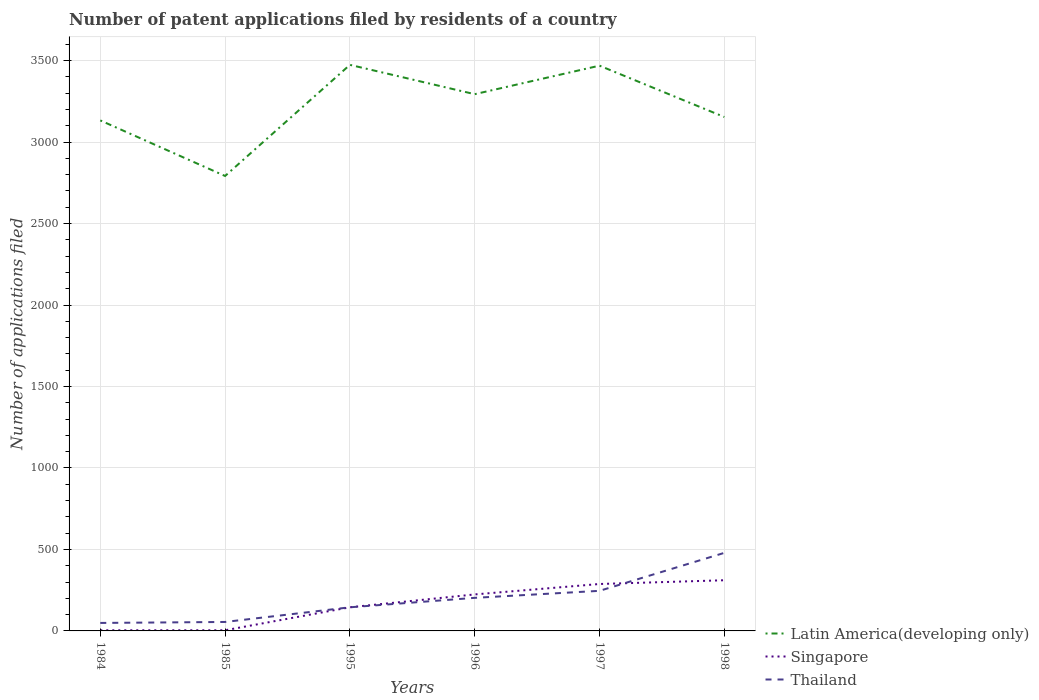Does the line corresponding to Singapore intersect with the line corresponding to Latin America(developing only)?
Keep it short and to the point. No. Is the number of lines equal to the number of legend labels?
Your answer should be very brief. Yes. What is the total number of applications filed in Thailand in the graph?
Offer a very short reply. -197. What is the difference between the highest and the second highest number of applications filed in Thailand?
Keep it short and to the point. 430. How many lines are there?
Ensure brevity in your answer.  3. How many years are there in the graph?
Ensure brevity in your answer.  6. How many legend labels are there?
Offer a very short reply. 3. What is the title of the graph?
Offer a terse response. Number of patent applications filed by residents of a country. What is the label or title of the Y-axis?
Make the answer very short. Number of applications filed. What is the Number of applications filed in Latin America(developing only) in 1984?
Provide a short and direct response. 3133. What is the Number of applications filed of Singapore in 1984?
Offer a very short reply. 4. What is the Number of applications filed in Latin America(developing only) in 1985?
Provide a succinct answer. 2792. What is the Number of applications filed in Singapore in 1985?
Give a very brief answer. 4. What is the Number of applications filed in Latin America(developing only) in 1995?
Offer a terse response. 3474. What is the Number of applications filed of Singapore in 1995?
Keep it short and to the point. 145. What is the Number of applications filed in Thailand in 1995?
Keep it short and to the point. 145. What is the Number of applications filed of Latin America(developing only) in 1996?
Provide a short and direct response. 3294. What is the Number of applications filed of Singapore in 1996?
Your answer should be compact. 224. What is the Number of applications filed in Thailand in 1996?
Provide a short and direct response. 203. What is the Number of applications filed in Latin America(developing only) in 1997?
Provide a short and direct response. 3469. What is the Number of applications filed of Singapore in 1997?
Your answer should be compact. 288. What is the Number of applications filed of Thailand in 1997?
Your response must be concise. 246. What is the Number of applications filed in Latin America(developing only) in 1998?
Your answer should be very brief. 3154. What is the Number of applications filed in Singapore in 1998?
Offer a terse response. 311. What is the Number of applications filed of Thailand in 1998?
Your response must be concise. 479. Across all years, what is the maximum Number of applications filed in Latin America(developing only)?
Make the answer very short. 3474. Across all years, what is the maximum Number of applications filed of Singapore?
Provide a short and direct response. 311. Across all years, what is the maximum Number of applications filed in Thailand?
Your answer should be compact. 479. Across all years, what is the minimum Number of applications filed of Latin America(developing only)?
Give a very brief answer. 2792. Across all years, what is the minimum Number of applications filed in Thailand?
Make the answer very short. 49. What is the total Number of applications filed in Latin America(developing only) in the graph?
Offer a very short reply. 1.93e+04. What is the total Number of applications filed in Singapore in the graph?
Your answer should be very brief. 976. What is the total Number of applications filed of Thailand in the graph?
Your response must be concise. 1177. What is the difference between the Number of applications filed of Latin America(developing only) in 1984 and that in 1985?
Make the answer very short. 341. What is the difference between the Number of applications filed of Thailand in 1984 and that in 1985?
Your response must be concise. -6. What is the difference between the Number of applications filed in Latin America(developing only) in 1984 and that in 1995?
Your response must be concise. -341. What is the difference between the Number of applications filed in Singapore in 1984 and that in 1995?
Give a very brief answer. -141. What is the difference between the Number of applications filed of Thailand in 1984 and that in 1995?
Give a very brief answer. -96. What is the difference between the Number of applications filed of Latin America(developing only) in 1984 and that in 1996?
Offer a very short reply. -161. What is the difference between the Number of applications filed of Singapore in 1984 and that in 1996?
Make the answer very short. -220. What is the difference between the Number of applications filed of Thailand in 1984 and that in 1996?
Your response must be concise. -154. What is the difference between the Number of applications filed of Latin America(developing only) in 1984 and that in 1997?
Make the answer very short. -336. What is the difference between the Number of applications filed in Singapore in 1984 and that in 1997?
Your response must be concise. -284. What is the difference between the Number of applications filed in Thailand in 1984 and that in 1997?
Your answer should be compact. -197. What is the difference between the Number of applications filed of Singapore in 1984 and that in 1998?
Keep it short and to the point. -307. What is the difference between the Number of applications filed of Thailand in 1984 and that in 1998?
Your answer should be compact. -430. What is the difference between the Number of applications filed of Latin America(developing only) in 1985 and that in 1995?
Your answer should be very brief. -682. What is the difference between the Number of applications filed of Singapore in 1985 and that in 1995?
Ensure brevity in your answer.  -141. What is the difference between the Number of applications filed in Thailand in 1985 and that in 1995?
Your answer should be very brief. -90. What is the difference between the Number of applications filed in Latin America(developing only) in 1985 and that in 1996?
Ensure brevity in your answer.  -502. What is the difference between the Number of applications filed of Singapore in 1985 and that in 1996?
Your answer should be very brief. -220. What is the difference between the Number of applications filed in Thailand in 1985 and that in 1996?
Provide a short and direct response. -148. What is the difference between the Number of applications filed of Latin America(developing only) in 1985 and that in 1997?
Offer a terse response. -677. What is the difference between the Number of applications filed of Singapore in 1985 and that in 1997?
Your answer should be compact. -284. What is the difference between the Number of applications filed in Thailand in 1985 and that in 1997?
Your answer should be compact. -191. What is the difference between the Number of applications filed in Latin America(developing only) in 1985 and that in 1998?
Your answer should be very brief. -362. What is the difference between the Number of applications filed in Singapore in 1985 and that in 1998?
Make the answer very short. -307. What is the difference between the Number of applications filed of Thailand in 1985 and that in 1998?
Provide a succinct answer. -424. What is the difference between the Number of applications filed in Latin America(developing only) in 1995 and that in 1996?
Ensure brevity in your answer.  180. What is the difference between the Number of applications filed in Singapore in 1995 and that in 1996?
Ensure brevity in your answer.  -79. What is the difference between the Number of applications filed in Thailand in 1995 and that in 1996?
Provide a short and direct response. -58. What is the difference between the Number of applications filed in Latin America(developing only) in 1995 and that in 1997?
Your answer should be very brief. 5. What is the difference between the Number of applications filed of Singapore in 1995 and that in 1997?
Your answer should be compact. -143. What is the difference between the Number of applications filed in Thailand in 1995 and that in 1997?
Your answer should be very brief. -101. What is the difference between the Number of applications filed of Latin America(developing only) in 1995 and that in 1998?
Keep it short and to the point. 320. What is the difference between the Number of applications filed in Singapore in 1995 and that in 1998?
Provide a short and direct response. -166. What is the difference between the Number of applications filed in Thailand in 1995 and that in 1998?
Offer a terse response. -334. What is the difference between the Number of applications filed of Latin America(developing only) in 1996 and that in 1997?
Keep it short and to the point. -175. What is the difference between the Number of applications filed in Singapore in 1996 and that in 1997?
Offer a terse response. -64. What is the difference between the Number of applications filed of Thailand in 1996 and that in 1997?
Your answer should be very brief. -43. What is the difference between the Number of applications filed of Latin America(developing only) in 1996 and that in 1998?
Your response must be concise. 140. What is the difference between the Number of applications filed in Singapore in 1996 and that in 1998?
Make the answer very short. -87. What is the difference between the Number of applications filed of Thailand in 1996 and that in 1998?
Keep it short and to the point. -276. What is the difference between the Number of applications filed in Latin America(developing only) in 1997 and that in 1998?
Give a very brief answer. 315. What is the difference between the Number of applications filed in Singapore in 1997 and that in 1998?
Offer a very short reply. -23. What is the difference between the Number of applications filed in Thailand in 1997 and that in 1998?
Offer a very short reply. -233. What is the difference between the Number of applications filed of Latin America(developing only) in 1984 and the Number of applications filed of Singapore in 1985?
Offer a very short reply. 3129. What is the difference between the Number of applications filed in Latin America(developing only) in 1984 and the Number of applications filed in Thailand in 1985?
Your answer should be compact. 3078. What is the difference between the Number of applications filed of Singapore in 1984 and the Number of applications filed of Thailand in 1985?
Your answer should be very brief. -51. What is the difference between the Number of applications filed of Latin America(developing only) in 1984 and the Number of applications filed of Singapore in 1995?
Your answer should be compact. 2988. What is the difference between the Number of applications filed in Latin America(developing only) in 1984 and the Number of applications filed in Thailand in 1995?
Your response must be concise. 2988. What is the difference between the Number of applications filed of Singapore in 1984 and the Number of applications filed of Thailand in 1995?
Make the answer very short. -141. What is the difference between the Number of applications filed of Latin America(developing only) in 1984 and the Number of applications filed of Singapore in 1996?
Make the answer very short. 2909. What is the difference between the Number of applications filed in Latin America(developing only) in 1984 and the Number of applications filed in Thailand in 1996?
Make the answer very short. 2930. What is the difference between the Number of applications filed in Singapore in 1984 and the Number of applications filed in Thailand in 1996?
Offer a terse response. -199. What is the difference between the Number of applications filed of Latin America(developing only) in 1984 and the Number of applications filed of Singapore in 1997?
Make the answer very short. 2845. What is the difference between the Number of applications filed in Latin America(developing only) in 1984 and the Number of applications filed in Thailand in 1997?
Provide a succinct answer. 2887. What is the difference between the Number of applications filed in Singapore in 1984 and the Number of applications filed in Thailand in 1997?
Offer a very short reply. -242. What is the difference between the Number of applications filed in Latin America(developing only) in 1984 and the Number of applications filed in Singapore in 1998?
Your answer should be compact. 2822. What is the difference between the Number of applications filed of Latin America(developing only) in 1984 and the Number of applications filed of Thailand in 1998?
Provide a short and direct response. 2654. What is the difference between the Number of applications filed in Singapore in 1984 and the Number of applications filed in Thailand in 1998?
Make the answer very short. -475. What is the difference between the Number of applications filed of Latin America(developing only) in 1985 and the Number of applications filed of Singapore in 1995?
Provide a short and direct response. 2647. What is the difference between the Number of applications filed of Latin America(developing only) in 1985 and the Number of applications filed of Thailand in 1995?
Ensure brevity in your answer.  2647. What is the difference between the Number of applications filed in Singapore in 1985 and the Number of applications filed in Thailand in 1995?
Make the answer very short. -141. What is the difference between the Number of applications filed of Latin America(developing only) in 1985 and the Number of applications filed of Singapore in 1996?
Keep it short and to the point. 2568. What is the difference between the Number of applications filed in Latin America(developing only) in 1985 and the Number of applications filed in Thailand in 1996?
Ensure brevity in your answer.  2589. What is the difference between the Number of applications filed of Singapore in 1985 and the Number of applications filed of Thailand in 1996?
Ensure brevity in your answer.  -199. What is the difference between the Number of applications filed of Latin America(developing only) in 1985 and the Number of applications filed of Singapore in 1997?
Give a very brief answer. 2504. What is the difference between the Number of applications filed in Latin America(developing only) in 1985 and the Number of applications filed in Thailand in 1997?
Ensure brevity in your answer.  2546. What is the difference between the Number of applications filed of Singapore in 1985 and the Number of applications filed of Thailand in 1997?
Ensure brevity in your answer.  -242. What is the difference between the Number of applications filed of Latin America(developing only) in 1985 and the Number of applications filed of Singapore in 1998?
Keep it short and to the point. 2481. What is the difference between the Number of applications filed of Latin America(developing only) in 1985 and the Number of applications filed of Thailand in 1998?
Keep it short and to the point. 2313. What is the difference between the Number of applications filed of Singapore in 1985 and the Number of applications filed of Thailand in 1998?
Your response must be concise. -475. What is the difference between the Number of applications filed of Latin America(developing only) in 1995 and the Number of applications filed of Singapore in 1996?
Ensure brevity in your answer.  3250. What is the difference between the Number of applications filed of Latin America(developing only) in 1995 and the Number of applications filed of Thailand in 1996?
Your answer should be very brief. 3271. What is the difference between the Number of applications filed of Singapore in 1995 and the Number of applications filed of Thailand in 1996?
Provide a short and direct response. -58. What is the difference between the Number of applications filed in Latin America(developing only) in 1995 and the Number of applications filed in Singapore in 1997?
Offer a very short reply. 3186. What is the difference between the Number of applications filed in Latin America(developing only) in 1995 and the Number of applications filed in Thailand in 1997?
Keep it short and to the point. 3228. What is the difference between the Number of applications filed of Singapore in 1995 and the Number of applications filed of Thailand in 1997?
Provide a short and direct response. -101. What is the difference between the Number of applications filed of Latin America(developing only) in 1995 and the Number of applications filed of Singapore in 1998?
Your answer should be compact. 3163. What is the difference between the Number of applications filed of Latin America(developing only) in 1995 and the Number of applications filed of Thailand in 1998?
Keep it short and to the point. 2995. What is the difference between the Number of applications filed in Singapore in 1995 and the Number of applications filed in Thailand in 1998?
Ensure brevity in your answer.  -334. What is the difference between the Number of applications filed of Latin America(developing only) in 1996 and the Number of applications filed of Singapore in 1997?
Make the answer very short. 3006. What is the difference between the Number of applications filed of Latin America(developing only) in 1996 and the Number of applications filed of Thailand in 1997?
Offer a very short reply. 3048. What is the difference between the Number of applications filed of Latin America(developing only) in 1996 and the Number of applications filed of Singapore in 1998?
Offer a very short reply. 2983. What is the difference between the Number of applications filed in Latin America(developing only) in 1996 and the Number of applications filed in Thailand in 1998?
Your answer should be very brief. 2815. What is the difference between the Number of applications filed of Singapore in 1996 and the Number of applications filed of Thailand in 1998?
Your answer should be very brief. -255. What is the difference between the Number of applications filed of Latin America(developing only) in 1997 and the Number of applications filed of Singapore in 1998?
Provide a succinct answer. 3158. What is the difference between the Number of applications filed in Latin America(developing only) in 1997 and the Number of applications filed in Thailand in 1998?
Offer a terse response. 2990. What is the difference between the Number of applications filed in Singapore in 1997 and the Number of applications filed in Thailand in 1998?
Offer a terse response. -191. What is the average Number of applications filed in Latin America(developing only) per year?
Offer a very short reply. 3219.33. What is the average Number of applications filed in Singapore per year?
Your response must be concise. 162.67. What is the average Number of applications filed in Thailand per year?
Your answer should be very brief. 196.17. In the year 1984, what is the difference between the Number of applications filed of Latin America(developing only) and Number of applications filed of Singapore?
Give a very brief answer. 3129. In the year 1984, what is the difference between the Number of applications filed in Latin America(developing only) and Number of applications filed in Thailand?
Your answer should be very brief. 3084. In the year 1984, what is the difference between the Number of applications filed in Singapore and Number of applications filed in Thailand?
Provide a succinct answer. -45. In the year 1985, what is the difference between the Number of applications filed of Latin America(developing only) and Number of applications filed of Singapore?
Make the answer very short. 2788. In the year 1985, what is the difference between the Number of applications filed of Latin America(developing only) and Number of applications filed of Thailand?
Provide a short and direct response. 2737. In the year 1985, what is the difference between the Number of applications filed in Singapore and Number of applications filed in Thailand?
Your answer should be very brief. -51. In the year 1995, what is the difference between the Number of applications filed in Latin America(developing only) and Number of applications filed in Singapore?
Provide a succinct answer. 3329. In the year 1995, what is the difference between the Number of applications filed of Latin America(developing only) and Number of applications filed of Thailand?
Your response must be concise. 3329. In the year 1995, what is the difference between the Number of applications filed in Singapore and Number of applications filed in Thailand?
Make the answer very short. 0. In the year 1996, what is the difference between the Number of applications filed of Latin America(developing only) and Number of applications filed of Singapore?
Ensure brevity in your answer.  3070. In the year 1996, what is the difference between the Number of applications filed of Latin America(developing only) and Number of applications filed of Thailand?
Provide a short and direct response. 3091. In the year 1996, what is the difference between the Number of applications filed in Singapore and Number of applications filed in Thailand?
Keep it short and to the point. 21. In the year 1997, what is the difference between the Number of applications filed of Latin America(developing only) and Number of applications filed of Singapore?
Make the answer very short. 3181. In the year 1997, what is the difference between the Number of applications filed of Latin America(developing only) and Number of applications filed of Thailand?
Offer a terse response. 3223. In the year 1997, what is the difference between the Number of applications filed in Singapore and Number of applications filed in Thailand?
Offer a very short reply. 42. In the year 1998, what is the difference between the Number of applications filed in Latin America(developing only) and Number of applications filed in Singapore?
Keep it short and to the point. 2843. In the year 1998, what is the difference between the Number of applications filed of Latin America(developing only) and Number of applications filed of Thailand?
Provide a short and direct response. 2675. In the year 1998, what is the difference between the Number of applications filed in Singapore and Number of applications filed in Thailand?
Your response must be concise. -168. What is the ratio of the Number of applications filed of Latin America(developing only) in 1984 to that in 1985?
Your answer should be compact. 1.12. What is the ratio of the Number of applications filed in Singapore in 1984 to that in 1985?
Your answer should be compact. 1. What is the ratio of the Number of applications filed of Thailand in 1984 to that in 1985?
Your response must be concise. 0.89. What is the ratio of the Number of applications filed of Latin America(developing only) in 1984 to that in 1995?
Keep it short and to the point. 0.9. What is the ratio of the Number of applications filed of Singapore in 1984 to that in 1995?
Offer a terse response. 0.03. What is the ratio of the Number of applications filed in Thailand in 1984 to that in 1995?
Keep it short and to the point. 0.34. What is the ratio of the Number of applications filed in Latin America(developing only) in 1984 to that in 1996?
Your answer should be compact. 0.95. What is the ratio of the Number of applications filed in Singapore in 1984 to that in 1996?
Give a very brief answer. 0.02. What is the ratio of the Number of applications filed in Thailand in 1984 to that in 1996?
Offer a terse response. 0.24. What is the ratio of the Number of applications filed of Latin America(developing only) in 1984 to that in 1997?
Offer a very short reply. 0.9. What is the ratio of the Number of applications filed in Singapore in 1984 to that in 1997?
Provide a succinct answer. 0.01. What is the ratio of the Number of applications filed of Thailand in 1984 to that in 1997?
Offer a very short reply. 0.2. What is the ratio of the Number of applications filed of Latin America(developing only) in 1984 to that in 1998?
Offer a terse response. 0.99. What is the ratio of the Number of applications filed of Singapore in 1984 to that in 1998?
Your answer should be compact. 0.01. What is the ratio of the Number of applications filed of Thailand in 1984 to that in 1998?
Give a very brief answer. 0.1. What is the ratio of the Number of applications filed in Latin America(developing only) in 1985 to that in 1995?
Offer a very short reply. 0.8. What is the ratio of the Number of applications filed of Singapore in 1985 to that in 1995?
Offer a terse response. 0.03. What is the ratio of the Number of applications filed of Thailand in 1985 to that in 1995?
Your response must be concise. 0.38. What is the ratio of the Number of applications filed of Latin America(developing only) in 1985 to that in 1996?
Provide a short and direct response. 0.85. What is the ratio of the Number of applications filed in Singapore in 1985 to that in 1996?
Your answer should be compact. 0.02. What is the ratio of the Number of applications filed in Thailand in 1985 to that in 1996?
Offer a terse response. 0.27. What is the ratio of the Number of applications filed of Latin America(developing only) in 1985 to that in 1997?
Provide a short and direct response. 0.8. What is the ratio of the Number of applications filed of Singapore in 1985 to that in 1997?
Your answer should be compact. 0.01. What is the ratio of the Number of applications filed in Thailand in 1985 to that in 1997?
Make the answer very short. 0.22. What is the ratio of the Number of applications filed in Latin America(developing only) in 1985 to that in 1998?
Give a very brief answer. 0.89. What is the ratio of the Number of applications filed of Singapore in 1985 to that in 1998?
Make the answer very short. 0.01. What is the ratio of the Number of applications filed of Thailand in 1985 to that in 1998?
Offer a terse response. 0.11. What is the ratio of the Number of applications filed in Latin America(developing only) in 1995 to that in 1996?
Your response must be concise. 1.05. What is the ratio of the Number of applications filed of Singapore in 1995 to that in 1996?
Keep it short and to the point. 0.65. What is the ratio of the Number of applications filed of Latin America(developing only) in 1995 to that in 1997?
Your answer should be compact. 1. What is the ratio of the Number of applications filed in Singapore in 1995 to that in 1997?
Your answer should be very brief. 0.5. What is the ratio of the Number of applications filed of Thailand in 1995 to that in 1997?
Offer a terse response. 0.59. What is the ratio of the Number of applications filed of Latin America(developing only) in 1995 to that in 1998?
Provide a succinct answer. 1.1. What is the ratio of the Number of applications filed in Singapore in 1995 to that in 1998?
Make the answer very short. 0.47. What is the ratio of the Number of applications filed of Thailand in 1995 to that in 1998?
Give a very brief answer. 0.3. What is the ratio of the Number of applications filed in Latin America(developing only) in 1996 to that in 1997?
Make the answer very short. 0.95. What is the ratio of the Number of applications filed in Thailand in 1996 to that in 1997?
Offer a terse response. 0.83. What is the ratio of the Number of applications filed of Latin America(developing only) in 1996 to that in 1998?
Give a very brief answer. 1.04. What is the ratio of the Number of applications filed in Singapore in 1996 to that in 1998?
Offer a very short reply. 0.72. What is the ratio of the Number of applications filed in Thailand in 1996 to that in 1998?
Provide a short and direct response. 0.42. What is the ratio of the Number of applications filed in Latin America(developing only) in 1997 to that in 1998?
Your response must be concise. 1.1. What is the ratio of the Number of applications filed of Singapore in 1997 to that in 1998?
Ensure brevity in your answer.  0.93. What is the ratio of the Number of applications filed in Thailand in 1997 to that in 1998?
Your answer should be compact. 0.51. What is the difference between the highest and the second highest Number of applications filed in Latin America(developing only)?
Make the answer very short. 5. What is the difference between the highest and the second highest Number of applications filed in Singapore?
Make the answer very short. 23. What is the difference between the highest and the second highest Number of applications filed of Thailand?
Your response must be concise. 233. What is the difference between the highest and the lowest Number of applications filed in Latin America(developing only)?
Give a very brief answer. 682. What is the difference between the highest and the lowest Number of applications filed of Singapore?
Your response must be concise. 307. What is the difference between the highest and the lowest Number of applications filed of Thailand?
Give a very brief answer. 430. 